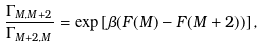<formula> <loc_0><loc_0><loc_500><loc_500>\frac { \Gamma _ { M , M + 2 } } { \Gamma _ { M + 2 , M } } = \exp \left [ \beta ( F ( M ) - F ( M + 2 ) ) \right ] ,</formula> 